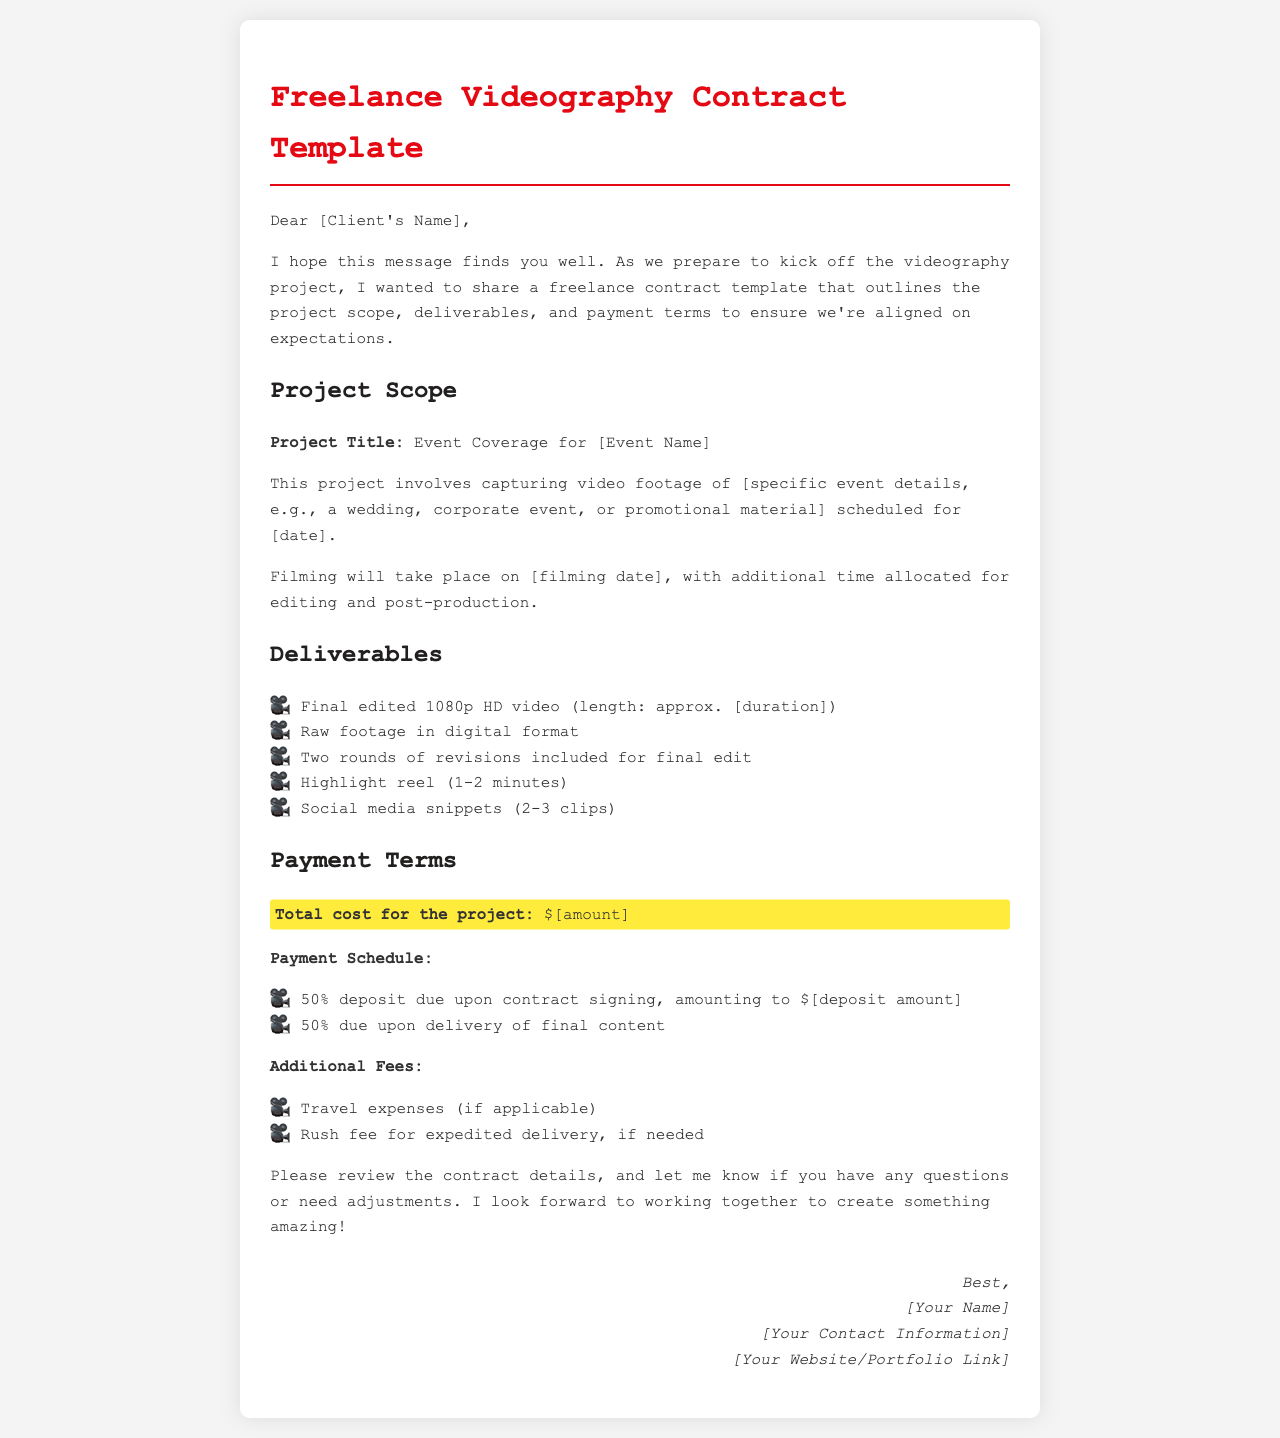what is the project title? The project title is specified in the document as "Event Coverage for [Event Name]."
Answer: Event Coverage for [Event Name] when is the filming date? The filming date is mentioned in the document simply as "[filming date]."
Answer: [filming date] how many rounds of revisions are included? The document states that "Two rounds of revisions included for final edit."
Answer: Two rounds what is the total cost for the project? The total cost for the project is highlighted in the document as "$[amount]."
Answer: $[amount] what percentage of the payment is required as a deposit? The document specifies that a 50% deposit is due upon contract signing.
Answer: 50% list one item included in the deliverables. The document lists several items in the deliverables section, such as "Final edited 1080p HD video (length: approx. [duration])."
Answer: Final edited 1080p HD video (length: approx. [duration]) what is the highlight reel length? The document states that the highlight reel should be "1-2 minutes."
Answer: 1-2 minutes are travel expenses included in the total cost? The document mentions that travel expenses may be applicable and are additional fees.
Answer: No, additional fees who should the email be addressed to? The email should be addressed to "[Client's Name]."
Answer: [Client's Name] 